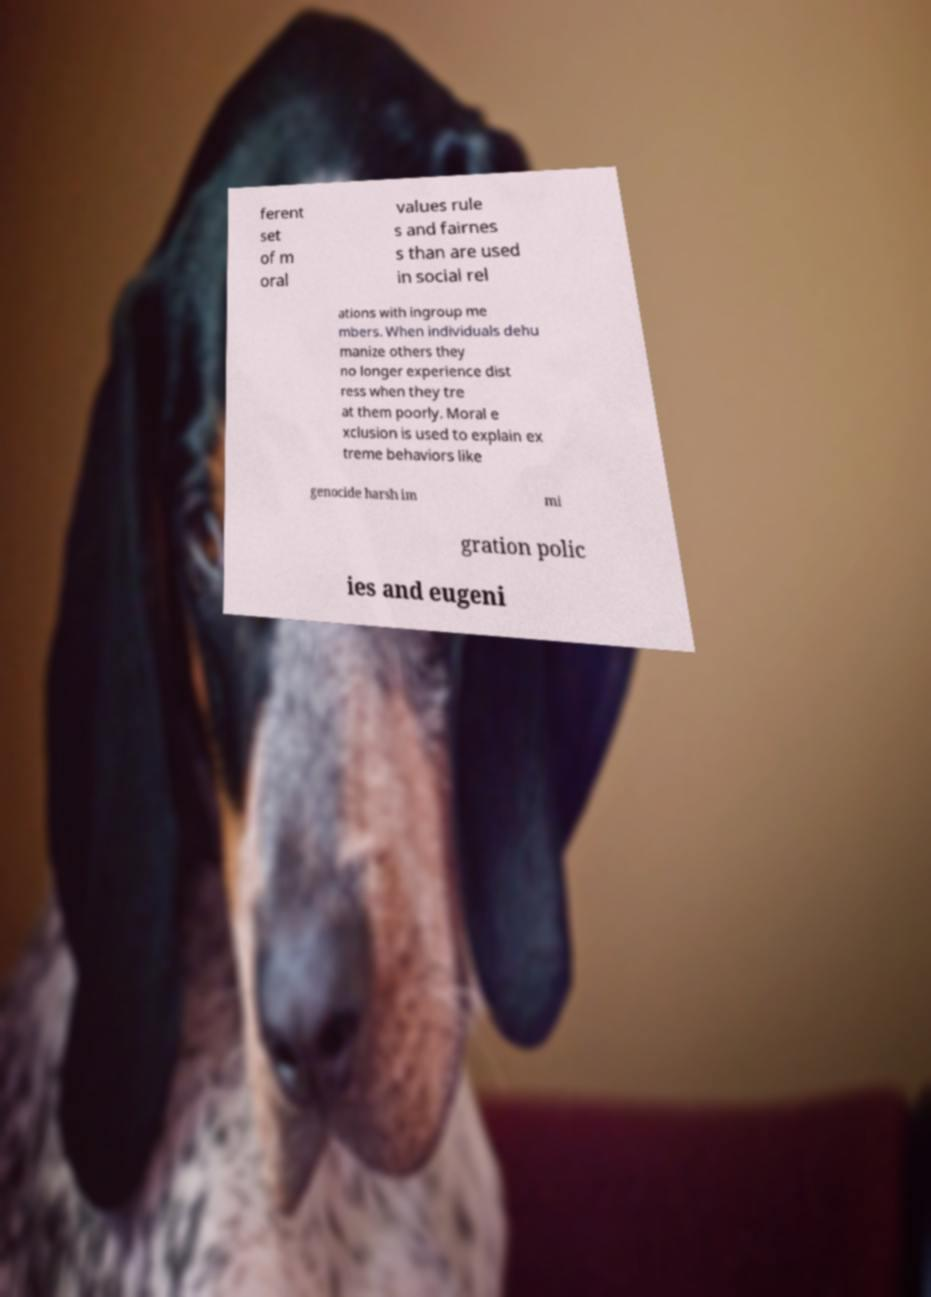Please identify and transcribe the text found in this image. ferent set of m oral values rule s and fairnes s than are used in social rel ations with ingroup me mbers. When individuals dehu manize others they no longer experience dist ress when they tre at them poorly. Moral e xclusion is used to explain ex treme behaviors like genocide harsh im mi gration polic ies and eugeni 